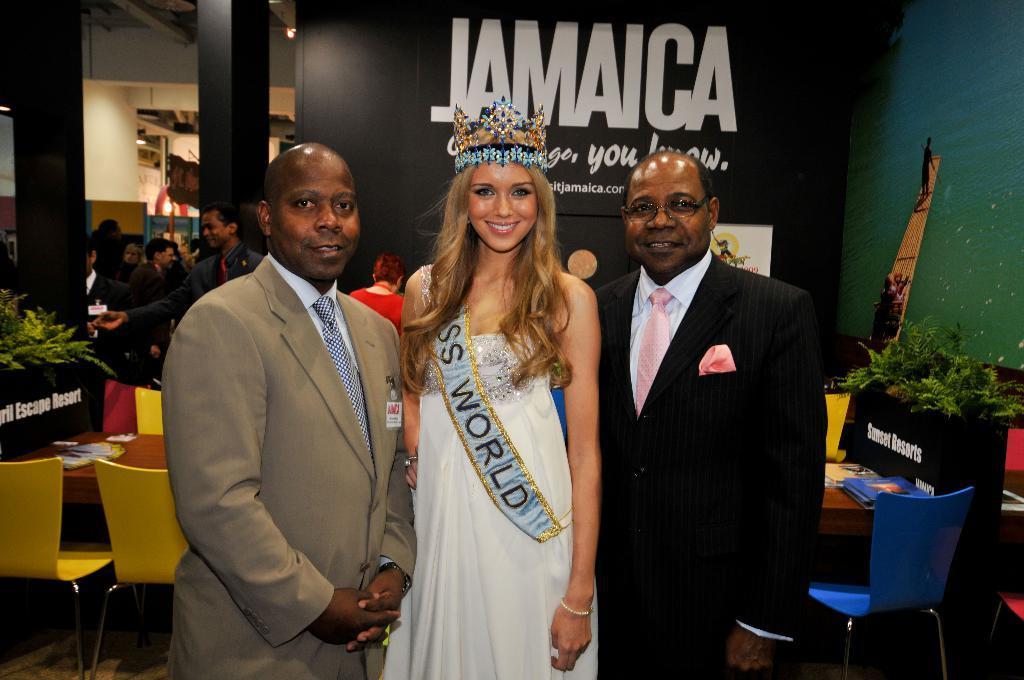Can you describe this image briefly? In this image we can see some persons. In the background of the image there are persons, plants, boards, wall, chairs, table and other objects. 